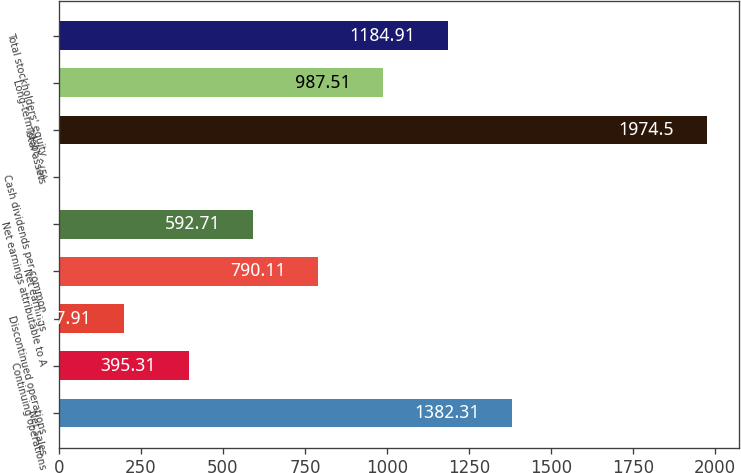<chart> <loc_0><loc_0><loc_500><loc_500><bar_chart><fcel>Net sales<fcel>Continuing operations<fcel>Discontinued operations<fcel>Net earnings<fcel>Net earnings attributable to A<fcel>Cash dividends per common<fcel>Total assets<fcel>Long-term debt ^(5)<fcel>Total stockholders' equity<nl><fcel>1382.31<fcel>395.31<fcel>197.91<fcel>790.11<fcel>592.71<fcel>0.51<fcel>1974.5<fcel>987.51<fcel>1184.91<nl></chart> 